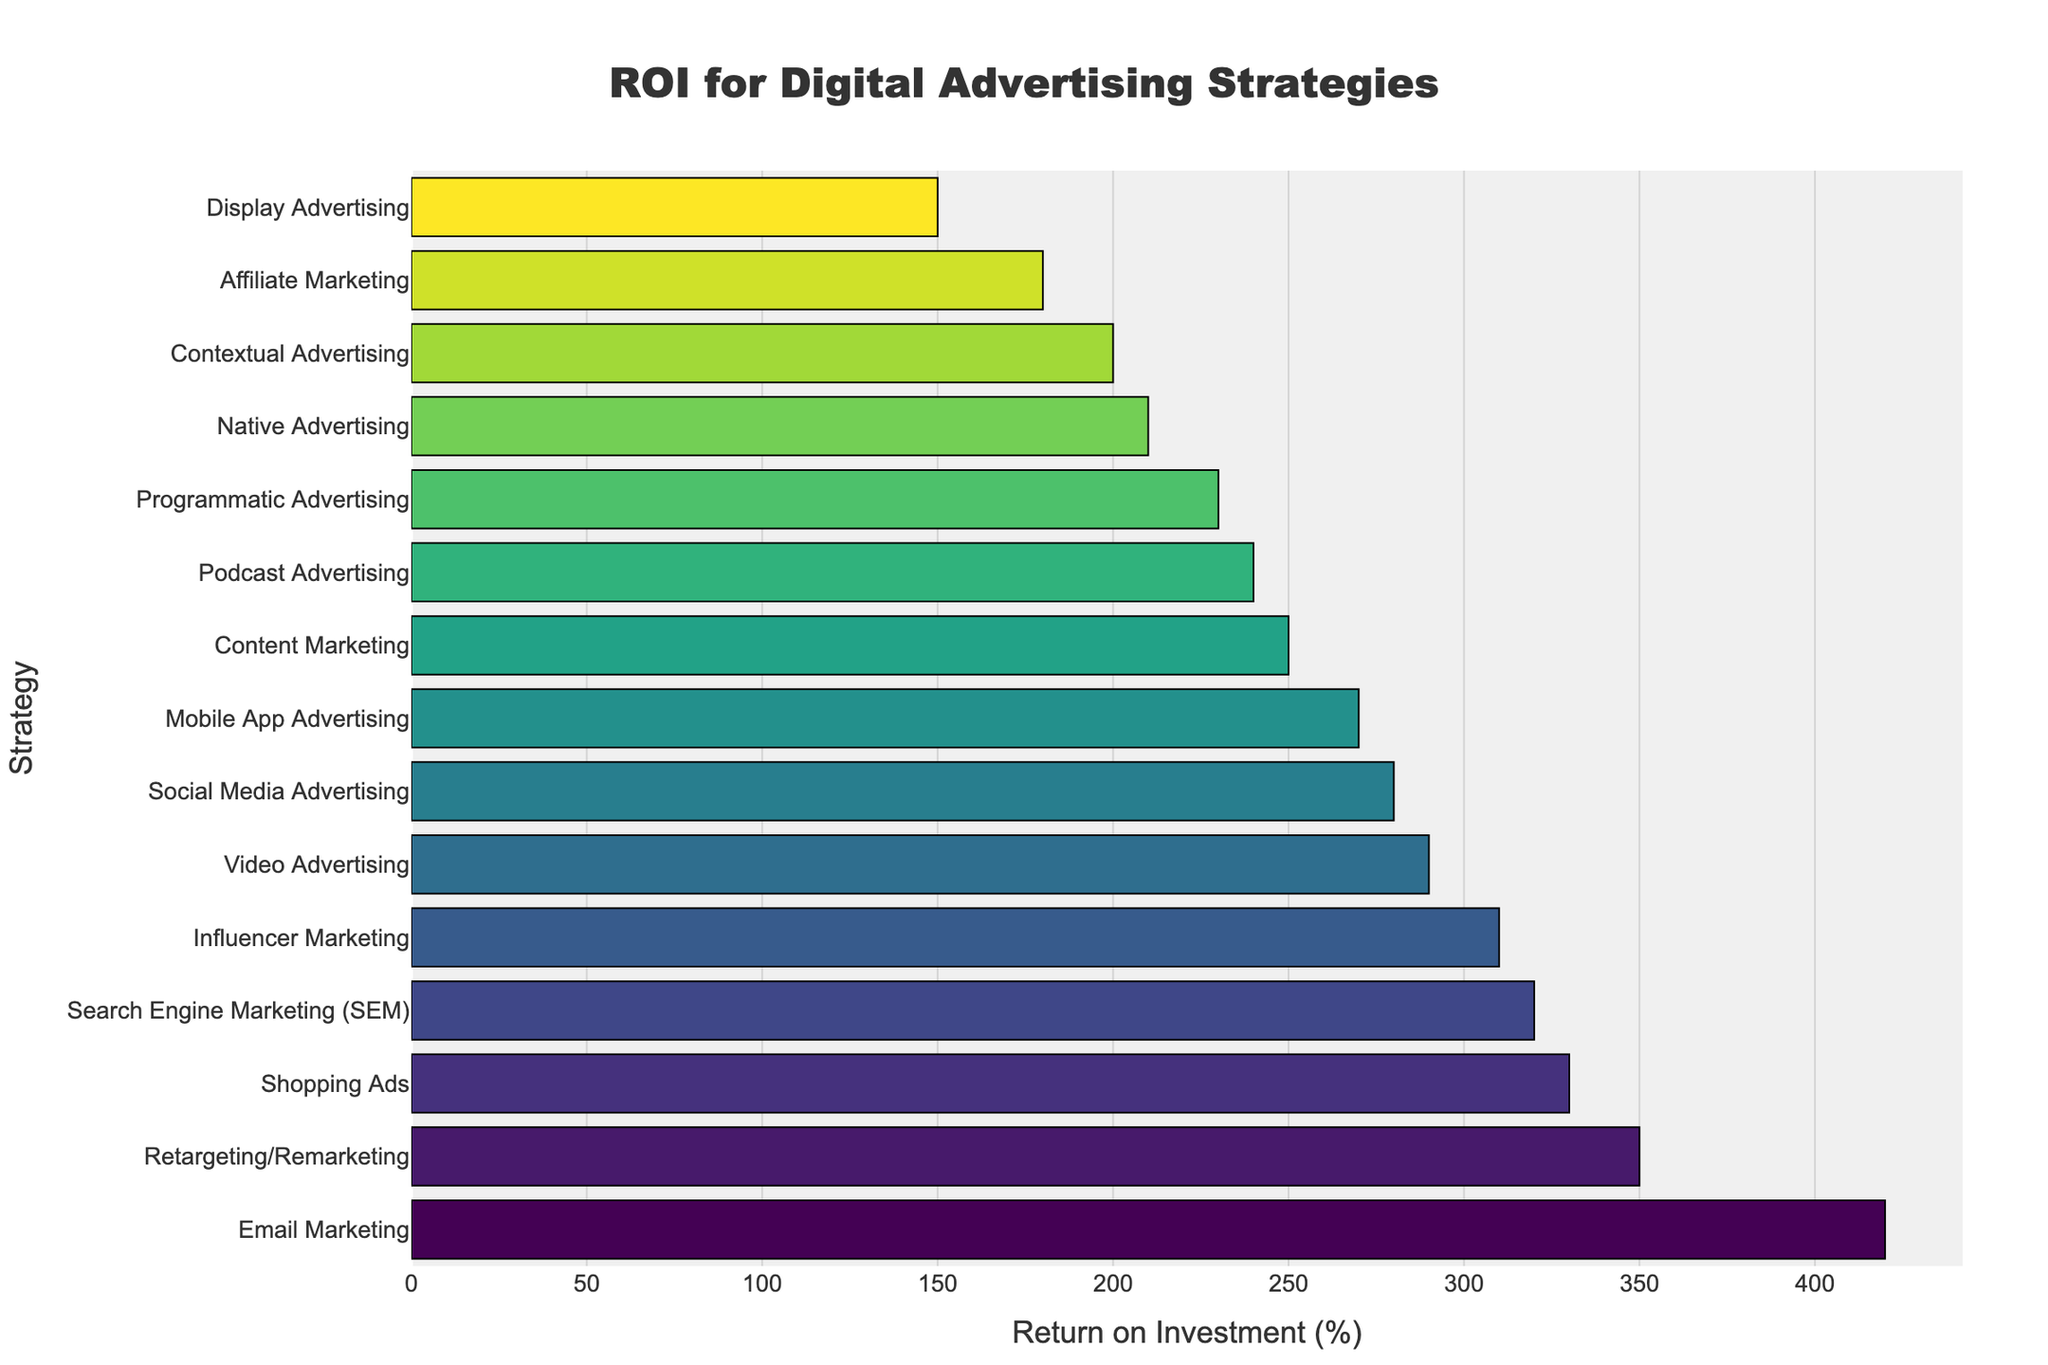Which strategy has the highest ROI? To find the strategy with the highest ROI, look for the bar that extends the furthest to the right. The longest bar represents Email Marketing at 420%.
Answer: Email Marketing What is the difference in ROI between the highest and lowest performing strategies? Identify the highest ROI (Email Marketing at 420%) and the lowest ROI (Display Advertising at 150%). Subtract the lowest from the highest (420 - 150).
Answer: 270% Which strategies have an ROI greater than 300%? Look at the bars that extend past the 300% mark. The strategies are Search Engine Marketing, Social Media Advertising, Email Marketing, Influencer Marketing, Retargeting/Remarketing, and Shopping Ads.
Answer: Search Engine Marketing, Social Media Advertising, Email Marketing, Influencer Marketing, Retargeting/Remarketing, Shopping Ads What is the average ROI of the three least performing strategies? Identify the three least performing strategies: Display Advertising (150%), Affiliate Marketing (180%), and Contextual Advertising (200%). Calculate the average (150+180+200)/3.
Answer: 176.67% Which strategies have an ROI between 200% and 300%? Identify the bars that lie within the specified range. The strategies are Content Marketing, Video Advertising, Native Advertising, Podcast Advertising, Mobile App Advertising, and Programmatic Advertising.
Answer: Content Marketing, Video Advertising, Native Advertising, Podcast Advertising, Mobile App Advertising, Programmatic Advertising How does the ROI of Social Media Advertising compare to Video Advertising? Locate the bars for Social Media Advertising (280%) and Video Advertising (290%). Social Media Advertising has a slightly lower ROI compared to Video Advertising.
Answer: Lower What is the median ROI value of all the strategies? There are 15 strategies. Order the ROI values and find the middle one. Ordered values: [150, 180, 200, 210, 230, 240, 250, 270, 280, 290, 310, 320, 330, 350, 420]. The median value is the 8th value.
Answer: 270% What is the combined ROI of Shopping Ads and Retargeting/Remarketing? Find and sum the ROIs of Shopping Ads (330%) and Retargeting/Remarketing (350%).
Answer: 680% What is the range of ROI values in the figure? Find the highest and lowest ROI values: 420% (Email Marketing) and 150% (Display Advertising). Subtract the lowest from the highest (420 - 150).
Answer: 270% Which strategy(s) have a similar ROI to Podcast Advertising? Identify the ROI of Podcast Advertising (240%) and look for similar values. The closest match is Native Advertising at 210%.
Answer: Native Advertising 